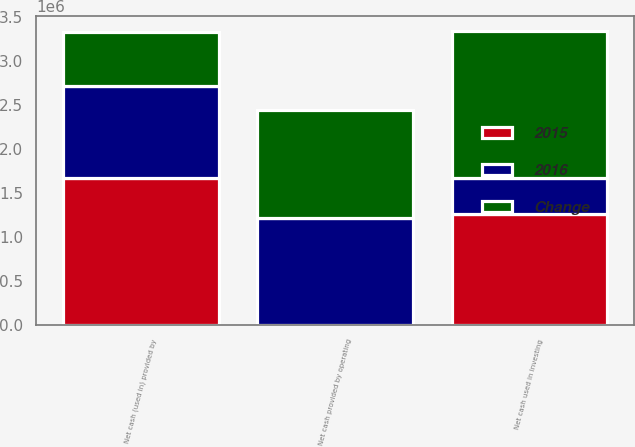<chart> <loc_0><loc_0><loc_500><loc_500><stacked_bar_chart><ecel><fcel>Net cash provided by operating<fcel>Net cash used in investing<fcel>Net cash (used in) provided by<nl><fcel>2016<fcel>1.21413e+06<fcel>410617<fcel>1.05426e+06<nl><fcel>Change<fcel>1.22214e+06<fcel>1.672e+06<fcel>614087<nl><fcel>2015<fcel>8014<fcel>1.26139e+06<fcel>1.66835e+06<nl></chart> 